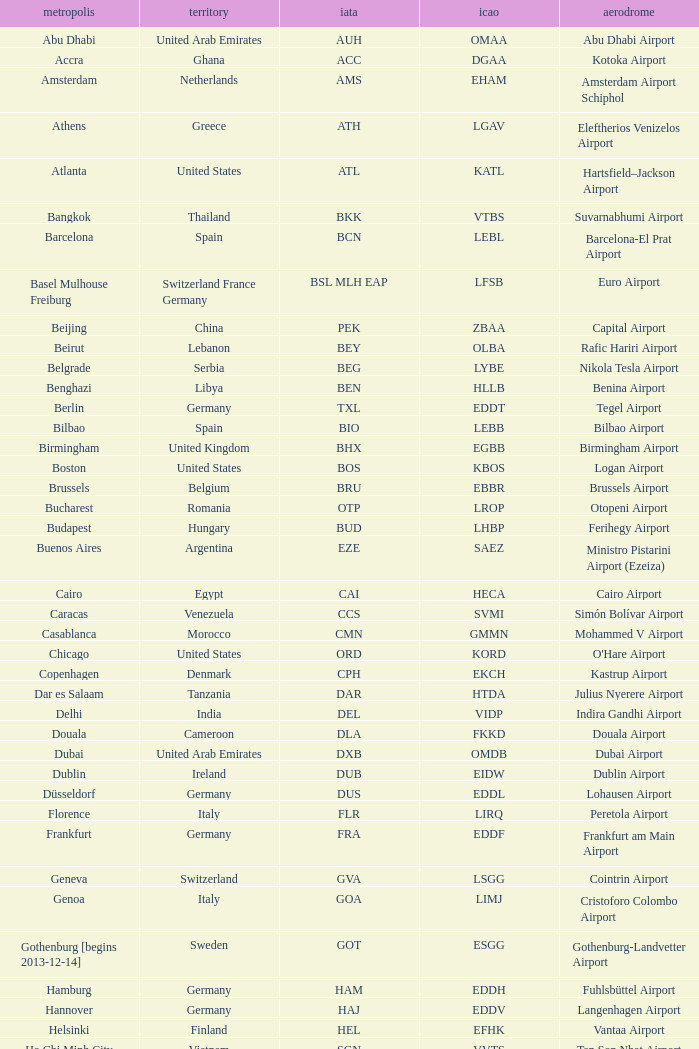What is the IATA for Ringway Airport in the United Kingdom? MAN. 